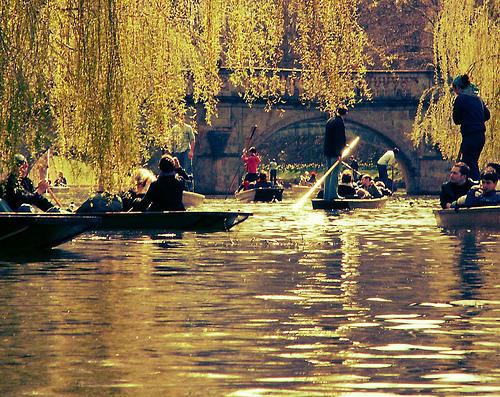Is this a boat race?
Quick response, please. No. Are they in a canal?
Answer briefly. Yes. How many boats are in the water?
Short answer required. 5. 